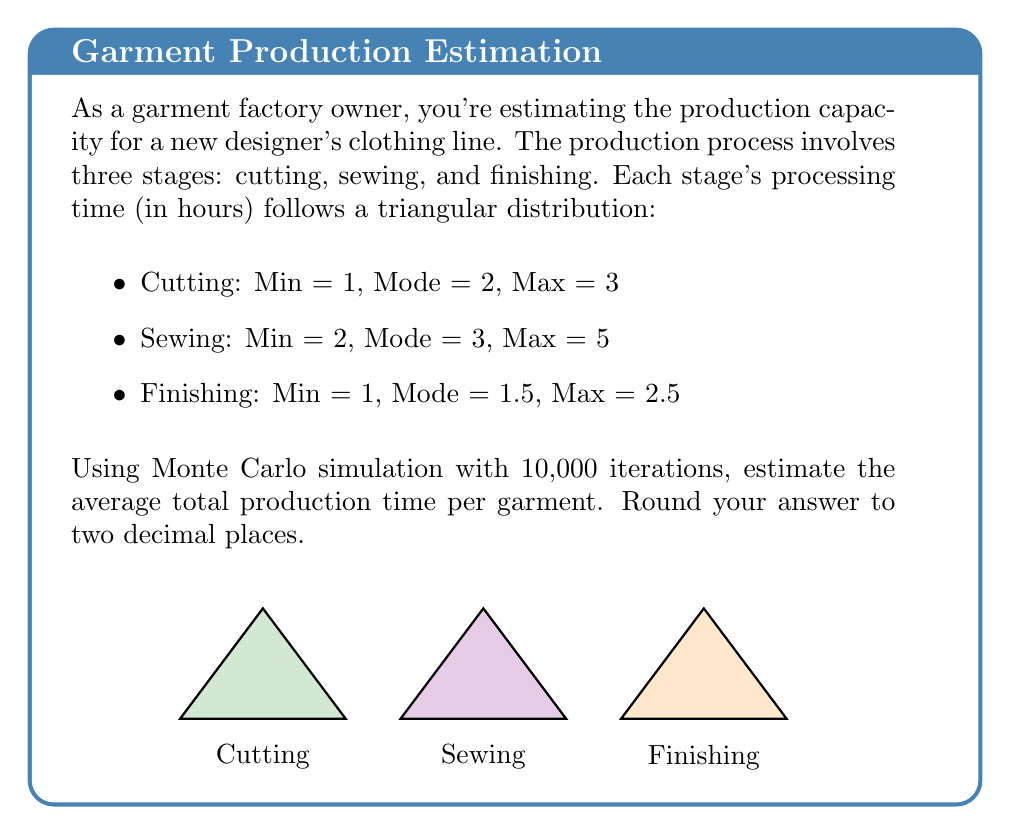Give your solution to this math problem. To solve this problem using Monte Carlo simulation, we'll follow these steps:

1) For each iteration, generate random times for each stage using the triangular distribution.

2) Sum these times to get the total production time for that iteration.

3) After all iterations, calculate the average of these total times.

Let's break it down:

1) Generating random times from a triangular distribution:
   For a triangular distribution with parameters (a, b, c), where a is the minimum, b is the mode, and c is the maximum, we can generate a random number using:

   $$X = \begin{cases} 
   a + \sqrt{U(b-a)(c-a)} & \text{if } U < \frac{b-a}{c-a} \\
   c - \sqrt{(1-U)(c-b)(c-a)} & \text{if } U \geq \frac{b-a}{c-a}
   \end{cases}$$

   Where $U$ is a uniform random number between 0 and 1.

2) For each iteration:
   - Generate $X_{\text{cutting}}$ using (1, 2, 3)
   - Generate $X_{\text{sewing}}$ using (2, 3, 5)
   - Generate $X_{\text{finishing}}$ using (1, 1.5, 2.5)
   - Calculate total time: $T = X_{\text{cutting}} + X_{\text{sewing}} + X_{\text{finishing}}$

3) After 10,000 iterations, calculate the average:
   $$\text{Average Time} = \frac{\sum_{i=1}^{10000} T_i}{10000}$$

Using a computer to perform this simulation (as it's impractical to do by hand), we would get a result close to 6.50 hours.
Answer: 6.50 hours 